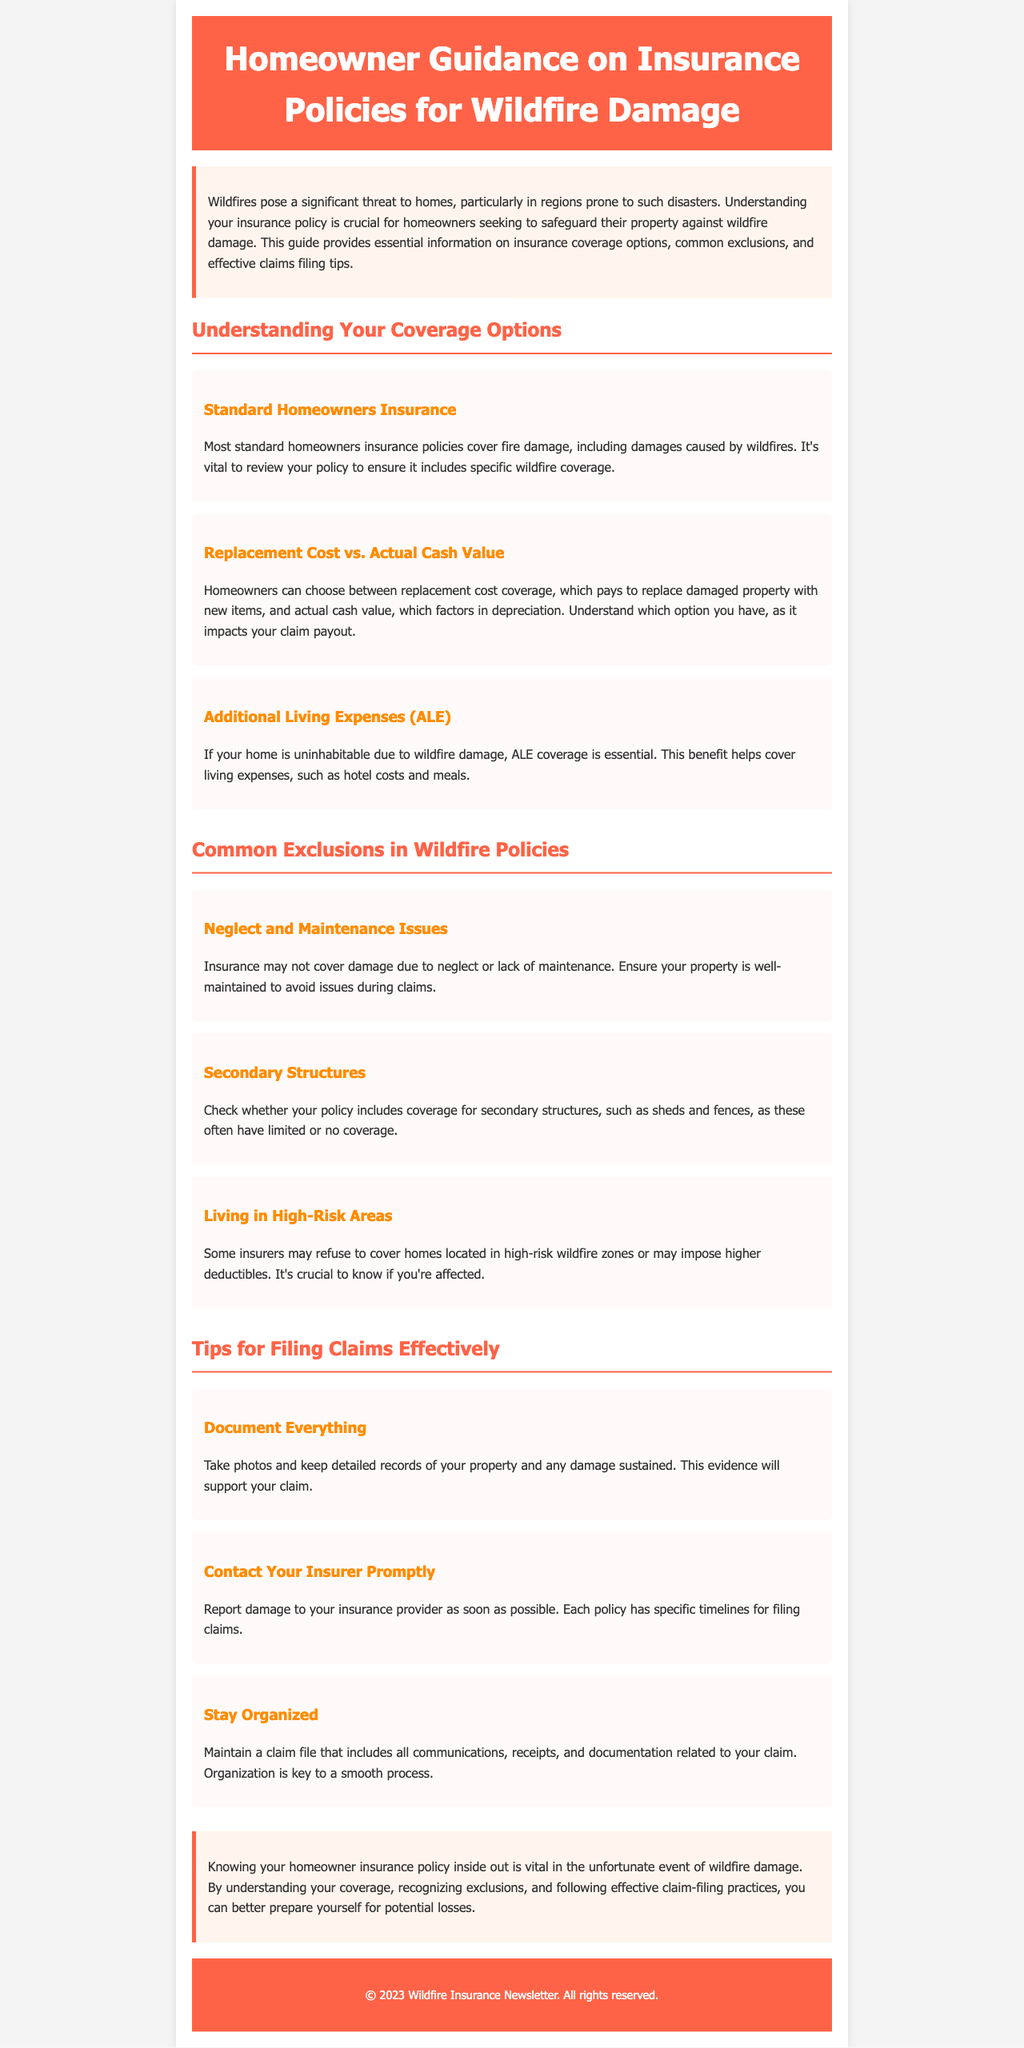What is the main threat to homes discussed in this document? The document discusses wildfires as a significant threat to homes, particularly in prone areas.
Answer: wildfires What is the purpose of Additional Living Expenses (ALE) coverage? ALE coverage is outlined as essential to cover living expenses if a home is uninhabitable due to wildfire damage.
Answer: living expenses What are the two types of coverage that homeowners can choose between? The document mentions replacement cost coverage and actual cash value as the two types of coverage homeowners can choose.
Answer: replacement cost and actual cash value What common exclusion relates to property maintenance? The document states that neglect and maintenance issues can lead to an exclusion from coverage during claims.
Answer: neglect and maintenance issues What should homeowners document to support their claims? The document emphasizes the importance of documenting everything, including photos and detailed records of property and damage.
Answer: everything What color is used for the section header titles? The section header titles are distinguished with a specific color mentioned in the document.
Answer: #FF6347 How many subsections are there in the "Common Exclusions in Wildfire Policies"? The section lists three subsections outlining common exclusions related to wildfire policies.
Answer: three What is a critical step homeowners should take promptly after fire damage? The document advises homeowners to report damage to their insurance provider as soon as possible after an incident.
Answer: contact your insurer What is one important organizational tip for filing claims? The document recommends maintaining a claim file that includes all communications, receipts, and documentation related to the claim.
Answer: stay organized 